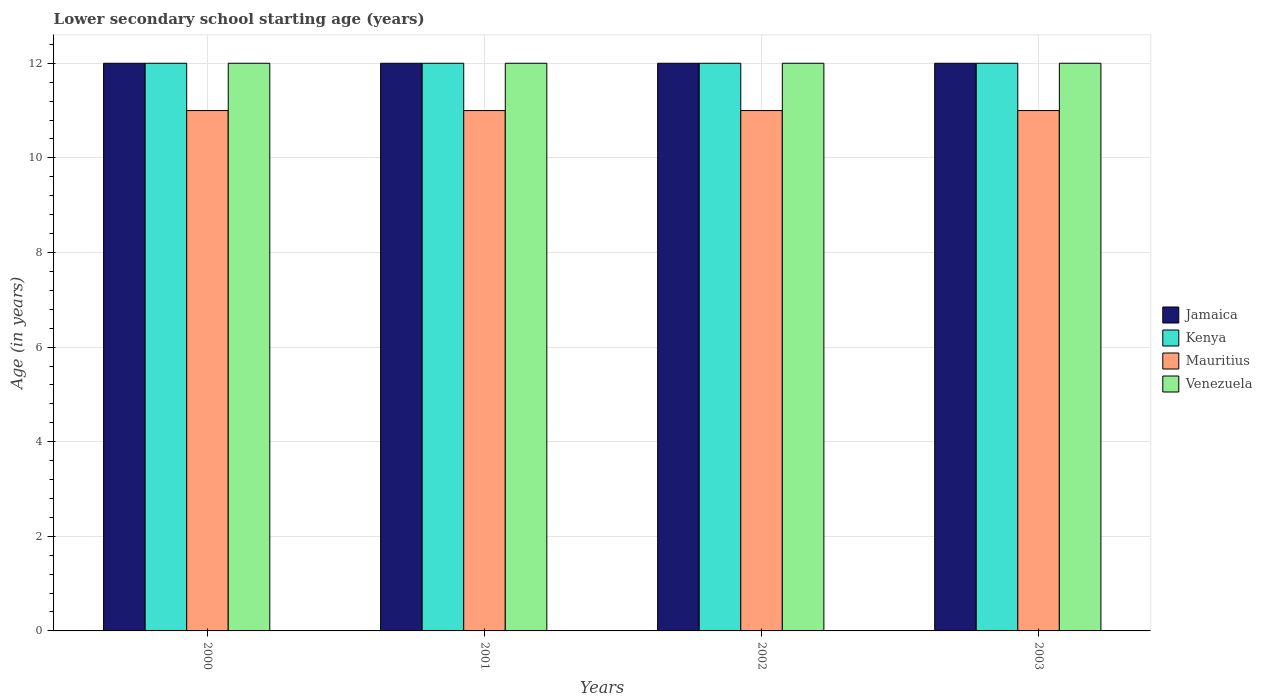How many different coloured bars are there?
Provide a succinct answer. 4. How many groups of bars are there?
Keep it short and to the point. 4. Are the number of bars per tick equal to the number of legend labels?
Offer a very short reply. Yes. How many bars are there on the 1st tick from the left?
Your answer should be compact. 4. What is the label of the 1st group of bars from the left?
Ensure brevity in your answer.  2000. In how many cases, is the number of bars for a given year not equal to the number of legend labels?
Keep it short and to the point. 0. What is the lower secondary school starting age of children in Mauritius in 2001?
Ensure brevity in your answer.  11. Across all years, what is the maximum lower secondary school starting age of children in Mauritius?
Provide a short and direct response. 11. Across all years, what is the minimum lower secondary school starting age of children in Mauritius?
Keep it short and to the point. 11. What is the total lower secondary school starting age of children in Mauritius in the graph?
Offer a very short reply. 44. In the year 2000, what is the difference between the lower secondary school starting age of children in Jamaica and lower secondary school starting age of children in Kenya?
Your answer should be very brief. 0. What is the difference between the highest and the lowest lower secondary school starting age of children in Kenya?
Make the answer very short. 0. In how many years, is the lower secondary school starting age of children in Mauritius greater than the average lower secondary school starting age of children in Mauritius taken over all years?
Give a very brief answer. 0. Is the sum of the lower secondary school starting age of children in Mauritius in 2000 and 2003 greater than the maximum lower secondary school starting age of children in Venezuela across all years?
Make the answer very short. Yes. What does the 4th bar from the left in 2002 represents?
Offer a very short reply. Venezuela. What does the 1st bar from the right in 2000 represents?
Make the answer very short. Venezuela. Is it the case that in every year, the sum of the lower secondary school starting age of children in Jamaica and lower secondary school starting age of children in Mauritius is greater than the lower secondary school starting age of children in Venezuela?
Offer a terse response. Yes. Are all the bars in the graph horizontal?
Your answer should be very brief. No. Where does the legend appear in the graph?
Keep it short and to the point. Center right. What is the title of the graph?
Your answer should be very brief. Lower secondary school starting age (years). Does "Vietnam" appear as one of the legend labels in the graph?
Provide a succinct answer. No. What is the label or title of the Y-axis?
Keep it short and to the point. Age (in years). What is the Age (in years) of Mauritius in 2000?
Give a very brief answer. 11. What is the Age (in years) in Jamaica in 2001?
Ensure brevity in your answer.  12. What is the Age (in years) in Kenya in 2002?
Provide a succinct answer. 12. What is the Age (in years) of Kenya in 2003?
Provide a short and direct response. 12. What is the Age (in years) of Mauritius in 2003?
Keep it short and to the point. 11. What is the Age (in years) in Venezuela in 2003?
Ensure brevity in your answer.  12. Across all years, what is the maximum Age (in years) in Jamaica?
Ensure brevity in your answer.  12. Across all years, what is the minimum Age (in years) of Jamaica?
Give a very brief answer. 12. Across all years, what is the minimum Age (in years) in Kenya?
Your answer should be very brief. 12. Across all years, what is the minimum Age (in years) in Mauritius?
Ensure brevity in your answer.  11. What is the total Age (in years) of Jamaica in the graph?
Keep it short and to the point. 48. What is the total Age (in years) in Kenya in the graph?
Your answer should be compact. 48. What is the total Age (in years) of Mauritius in the graph?
Your answer should be compact. 44. What is the difference between the Age (in years) in Mauritius in 2000 and that in 2001?
Your response must be concise. 0. What is the difference between the Age (in years) in Venezuela in 2000 and that in 2001?
Provide a short and direct response. 0. What is the difference between the Age (in years) of Kenya in 2000 and that in 2002?
Keep it short and to the point. 0. What is the difference between the Age (in years) in Kenya in 2000 and that in 2003?
Provide a succinct answer. 0. What is the difference between the Age (in years) in Jamaica in 2001 and that in 2002?
Give a very brief answer. 0. What is the difference between the Age (in years) of Kenya in 2001 and that in 2002?
Offer a terse response. 0. What is the difference between the Age (in years) of Mauritius in 2001 and that in 2002?
Provide a short and direct response. 0. What is the difference between the Age (in years) in Venezuela in 2001 and that in 2002?
Provide a succinct answer. 0. What is the difference between the Age (in years) in Jamaica in 2001 and that in 2003?
Provide a short and direct response. 0. What is the difference between the Age (in years) of Jamaica in 2002 and that in 2003?
Provide a short and direct response. 0. What is the difference between the Age (in years) of Mauritius in 2002 and that in 2003?
Your response must be concise. 0. What is the difference between the Age (in years) of Jamaica in 2000 and the Age (in years) of Kenya in 2001?
Ensure brevity in your answer.  0. What is the difference between the Age (in years) of Jamaica in 2000 and the Age (in years) of Mauritius in 2001?
Provide a short and direct response. 1. What is the difference between the Age (in years) in Jamaica in 2000 and the Age (in years) in Venezuela in 2001?
Your response must be concise. 0. What is the difference between the Age (in years) in Mauritius in 2000 and the Age (in years) in Venezuela in 2001?
Offer a terse response. -1. What is the difference between the Age (in years) in Jamaica in 2000 and the Age (in years) in Kenya in 2002?
Your answer should be compact. 0. What is the difference between the Age (in years) in Jamaica in 2000 and the Age (in years) in Mauritius in 2002?
Keep it short and to the point. 1. What is the difference between the Age (in years) of Kenya in 2000 and the Age (in years) of Mauritius in 2002?
Ensure brevity in your answer.  1. What is the difference between the Age (in years) of Kenya in 2000 and the Age (in years) of Venezuela in 2002?
Offer a terse response. 0. What is the difference between the Age (in years) in Jamaica in 2000 and the Age (in years) in Kenya in 2003?
Your answer should be very brief. 0. What is the difference between the Age (in years) in Mauritius in 2000 and the Age (in years) in Venezuela in 2003?
Your answer should be compact. -1. What is the difference between the Age (in years) of Jamaica in 2001 and the Age (in years) of Kenya in 2002?
Your answer should be compact. 0. What is the difference between the Age (in years) of Kenya in 2001 and the Age (in years) of Mauritius in 2002?
Offer a very short reply. 1. What is the difference between the Age (in years) in Jamaica in 2001 and the Age (in years) in Mauritius in 2003?
Your response must be concise. 1. What is the difference between the Age (in years) in Jamaica in 2002 and the Age (in years) in Kenya in 2003?
Keep it short and to the point. 0. What is the difference between the Age (in years) of Jamaica in 2002 and the Age (in years) of Venezuela in 2003?
Give a very brief answer. 0. What is the difference between the Age (in years) of Kenya in 2002 and the Age (in years) of Mauritius in 2003?
Your answer should be compact. 1. What is the difference between the Age (in years) of Kenya in 2002 and the Age (in years) of Venezuela in 2003?
Offer a terse response. 0. What is the average Age (in years) in Jamaica per year?
Offer a very short reply. 12. What is the average Age (in years) in Kenya per year?
Provide a short and direct response. 12. What is the average Age (in years) in Mauritius per year?
Make the answer very short. 11. What is the average Age (in years) of Venezuela per year?
Offer a very short reply. 12. In the year 2000, what is the difference between the Age (in years) of Jamaica and Age (in years) of Kenya?
Make the answer very short. 0. In the year 2000, what is the difference between the Age (in years) of Jamaica and Age (in years) of Mauritius?
Keep it short and to the point. 1. In the year 2000, what is the difference between the Age (in years) of Jamaica and Age (in years) of Venezuela?
Your answer should be compact. 0. In the year 2000, what is the difference between the Age (in years) in Kenya and Age (in years) in Mauritius?
Your response must be concise. 1. In the year 2000, what is the difference between the Age (in years) of Kenya and Age (in years) of Venezuela?
Your answer should be compact. 0. In the year 2000, what is the difference between the Age (in years) in Mauritius and Age (in years) in Venezuela?
Provide a succinct answer. -1. In the year 2001, what is the difference between the Age (in years) in Jamaica and Age (in years) in Kenya?
Make the answer very short. 0. In the year 2001, what is the difference between the Age (in years) of Jamaica and Age (in years) of Mauritius?
Your answer should be compact. 1. In the year 2001, what is the difference between the Age (in years) in Jamaica and Age (in years) in Venezuela?
Your answer should be very brief. 0. In the year 2001, what is the difference between the Age (in years) of Kenya and Age (in years) of Mauritius?
Your answer should be very brief. 1. In the year 2002, what is the difference between the Age (in years) of Jamaica and Age (in years) of Kenya?
Ensure brevity in your answer.  0. In the year 2002, what is the difference between the Age (in years) in Jamaica and Age (in years) in Venezuela?
Give a very brief answer. 0. In the year 2002, what is the difference between the Age (in years) of Kenya and Age (in years) of Venezuela?
Your answer should be very brief. 0. In the year 2002, what is the difference between the Age (in years) in Mauritius and Age (in years) in Venezuela?
Keep it short and to the point. -1. In the year 2003, what is the difference between the Age (in years) of Jamaica and Age (in years) of Venezuela?
Ensure brevity in your answer.  0. In the year 2003, what is the difference between the Age (in years) of Kenya and Age (in years) of Mauritius?
Offer a terse response. 1. In the year 2003, what is the difference between the Age (in years) in Kenya and Age (in years) in Venezuela?
Your answer should be very brief. 0. What is the ratio of the Age (in years) of Jamaica in 2000 to that in 2001?
Your response must be concise. 1. What is the ratio of the Age (in years) of Kenya in 2000 to that in 2001?
Ensure brevity in your answer.  1. What is the ratio of the Age (in years) of Mauritius in 2000 to that in 2001?
Provide a short and direct response. 1. What is the ratio of the Age (in years) in Jamaica in 2000 to that in 2002?
Your answer should be compact. 1. What is the ratio of the Age (in years) in Mauritius in 2000 to that in 2002?
Your answer should be compact. 1. What is the ratio of the Age (in years) of Venezuela in 2000 to that in 2002?
Keep it short and to the point. 1. What is the ratio of the Age (in years) in Mauritius in 2000 to that in 2003?
Your response must be concise. 1. What is the ratio of the Age (in years) in Jamaica in 2001 to that in 2002?
Your answer should be very brief. 1. What is the ratio of the Age (in years) in Kenya in 2001 to that in 2002?
Make the answer very short. 1. What is the ratio of the Age (in years) of Mauritius in 2001 to that in 2003?
Keep it short and to the point. 1. What is the ratio of the Age (in years) of Venezuela in 2001 to that in 2003?
Your answer should be very brief. 1. What is the ratio of the Age (in years) of Mauritius in 2002 to that in 2003?
Keep it short and to the point. 1. What is the ratio of the Age (in years) in Venezuela in 2002 to that in 2003?
Make the answer very short. 1. What is the difference between the highest and the second highest Age (in years) in Jamaica?
Your answer should be very brief. 0. 